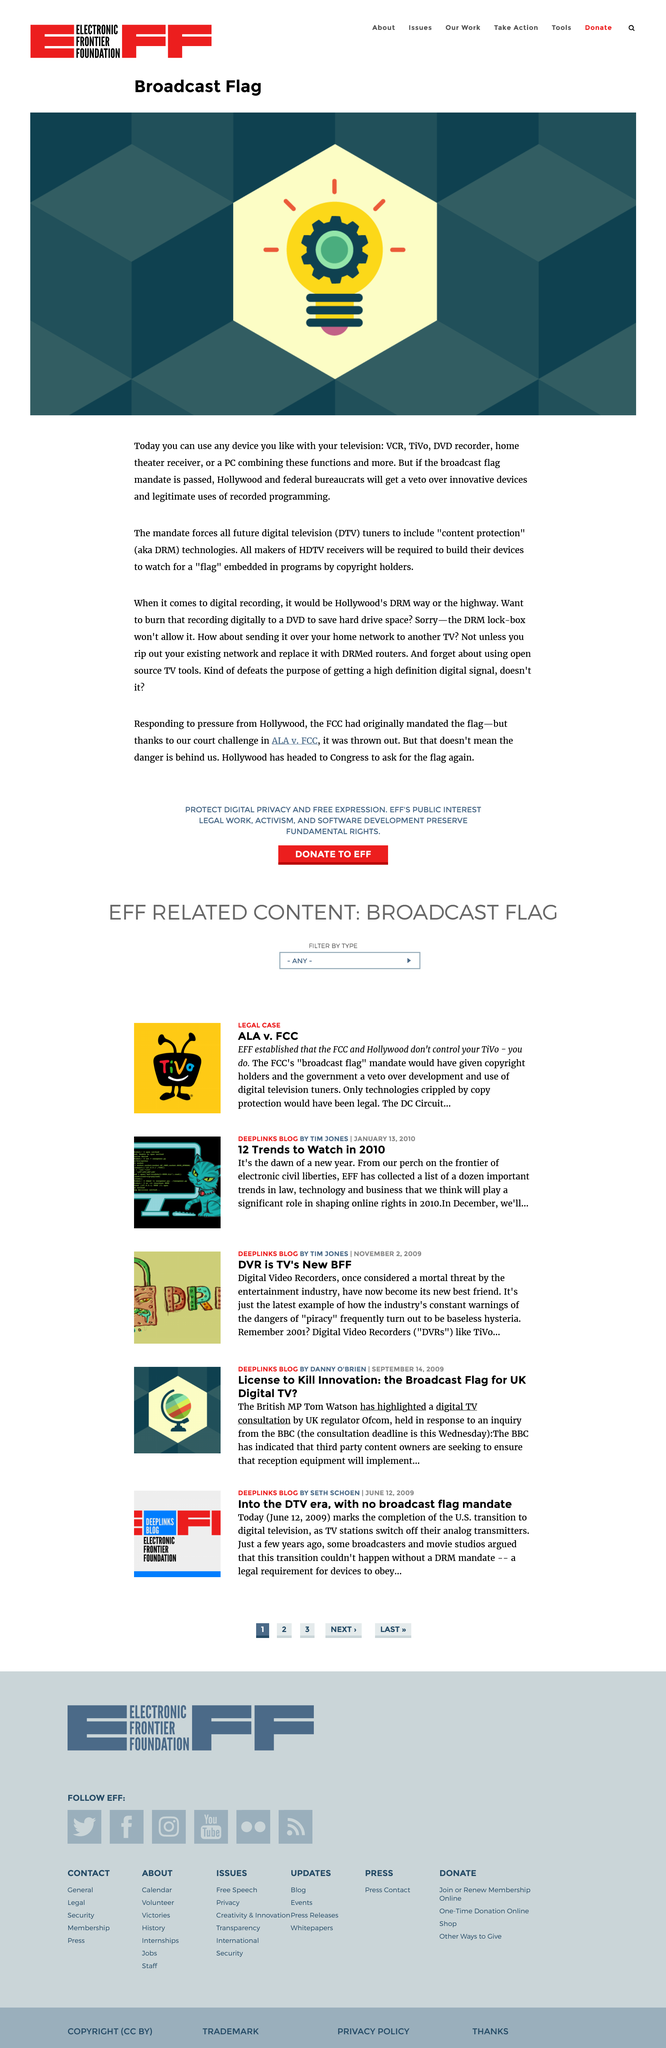Identify some key points in this picture. The mandate compels all future digital television (DTV) tuners to incorporate content protection features. The use of Hollywood's DRM lock-box in the future will prevent the saving of digital recordings to media such as DVDs. The Broadcast Flag Mandate, if passed, will render obsolete the use of television, VCR, TiVo, DVD Recorder, Home Theatre Receiver, and PC. 